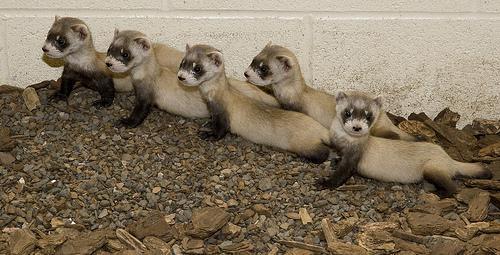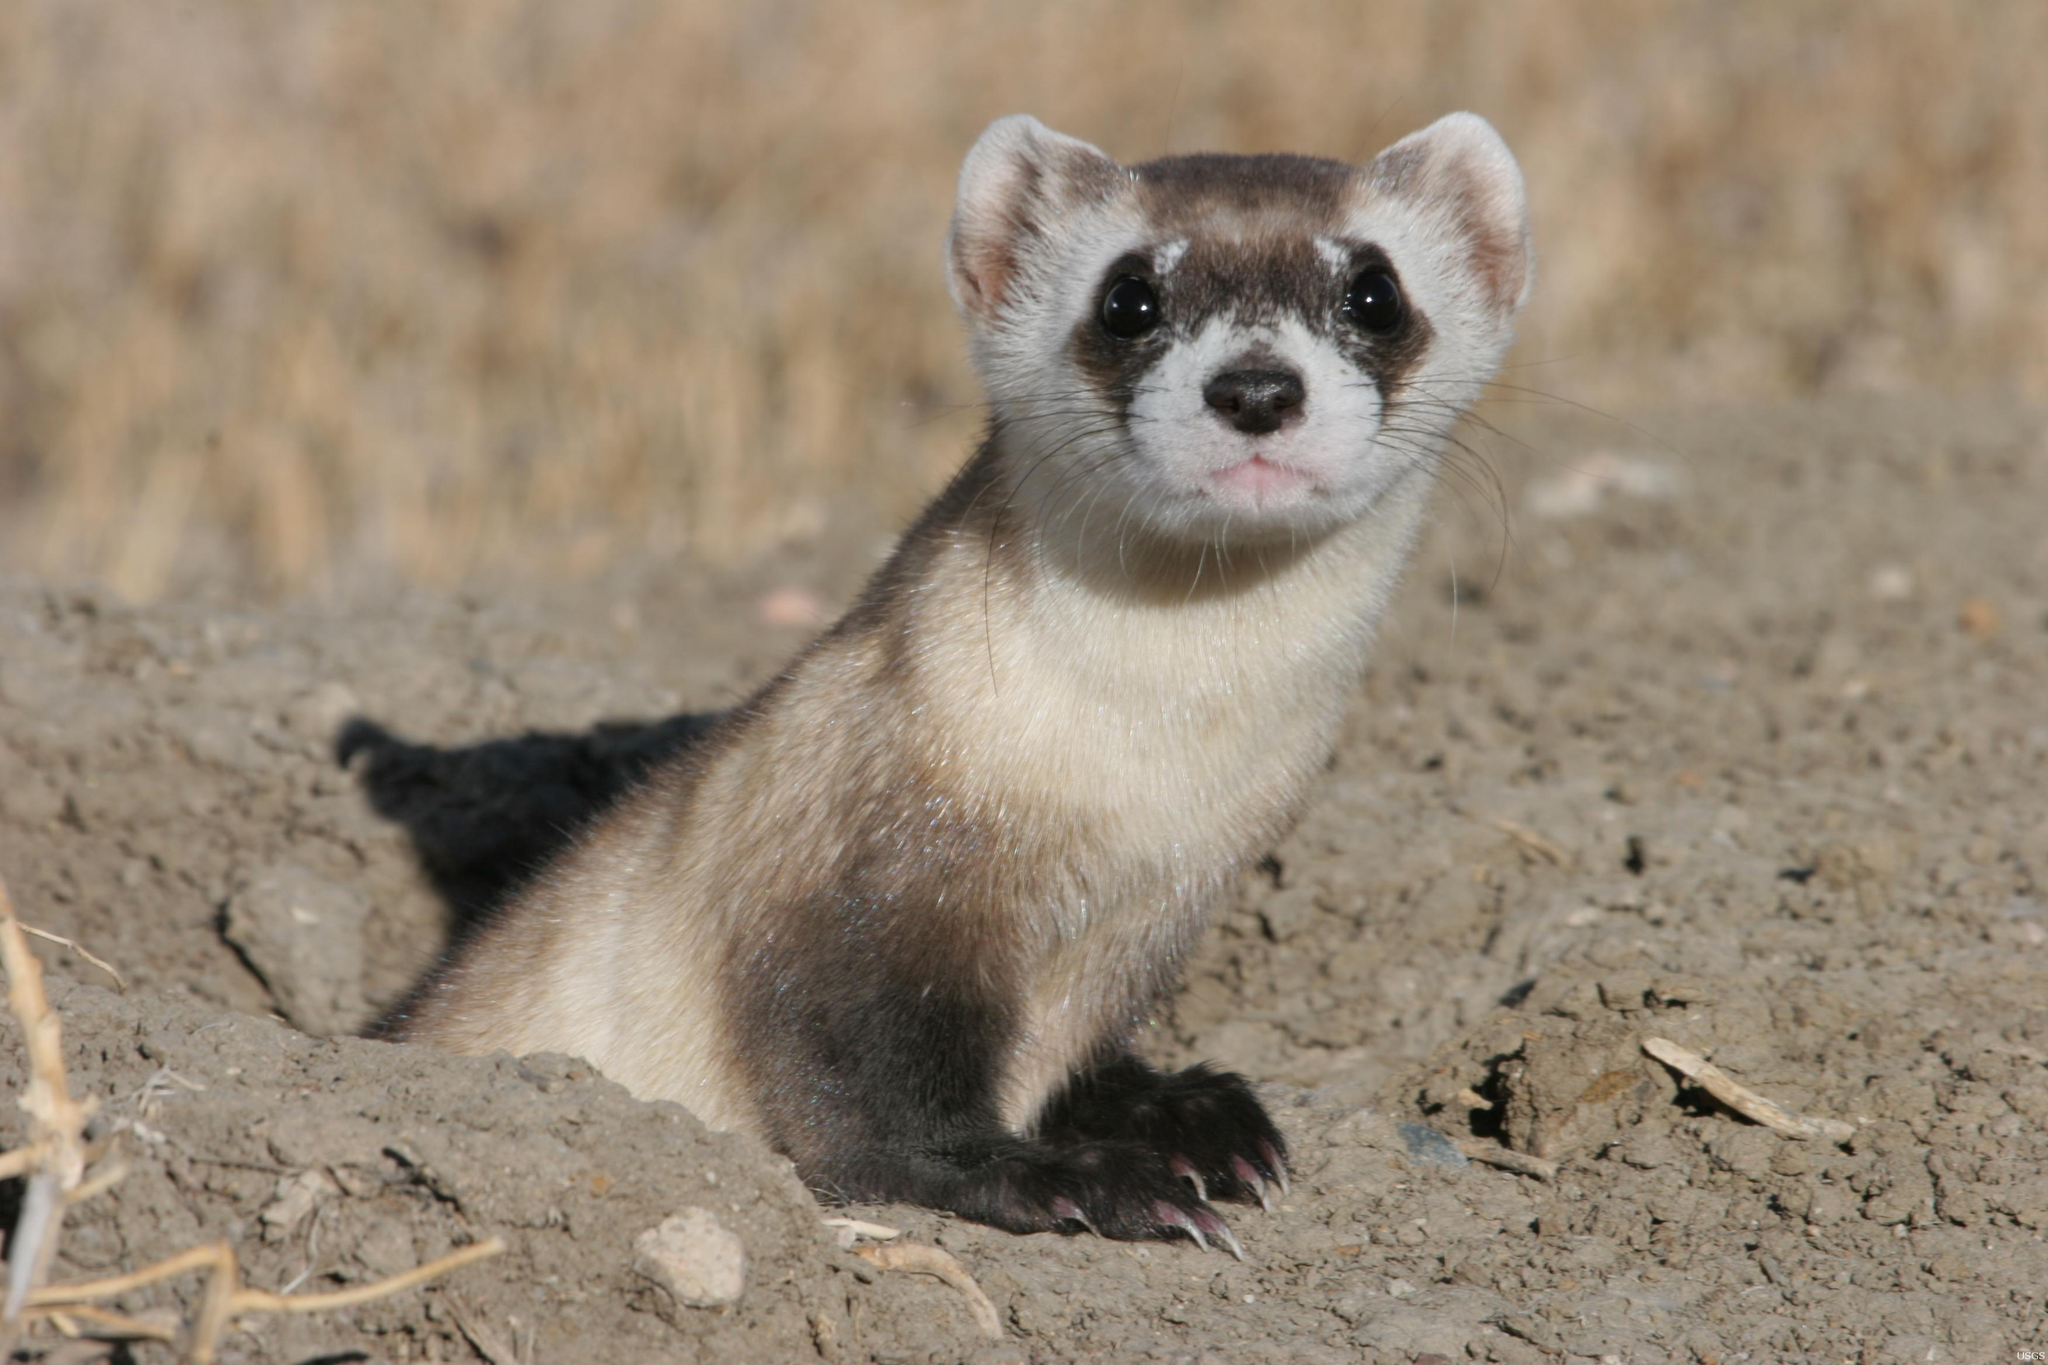The first image is the image on the left, the second image is the image on the right. Examine the images to the left and right. Is the description "An image contains a row of five ferrets." accurate? Answer yes or no. Yes. The first image is the image on the left, the second image is the image on the right. Assess this claim about the two images: "there are five animals in the image on the left". Correct or not? Answer yes or no. Yes. 